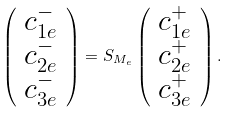<formula> <loc_0><loc_0><loc_500><loc_500>\left ( \begin{array} { c } c _ { 1 e } ^ { - } \\ c _ { 2 e } ^ { - } \\ c _ { 3 e } ^ { - } \end{array} \right ) = S _ { M _ { e } } \left ( \begin{array} { c } c _ { 1 e } ^ { + } \\ c _ { 2 e } ^ { + } \\ c _ { 3 e } ^ { + } \end{array} \right ) .</formula> 